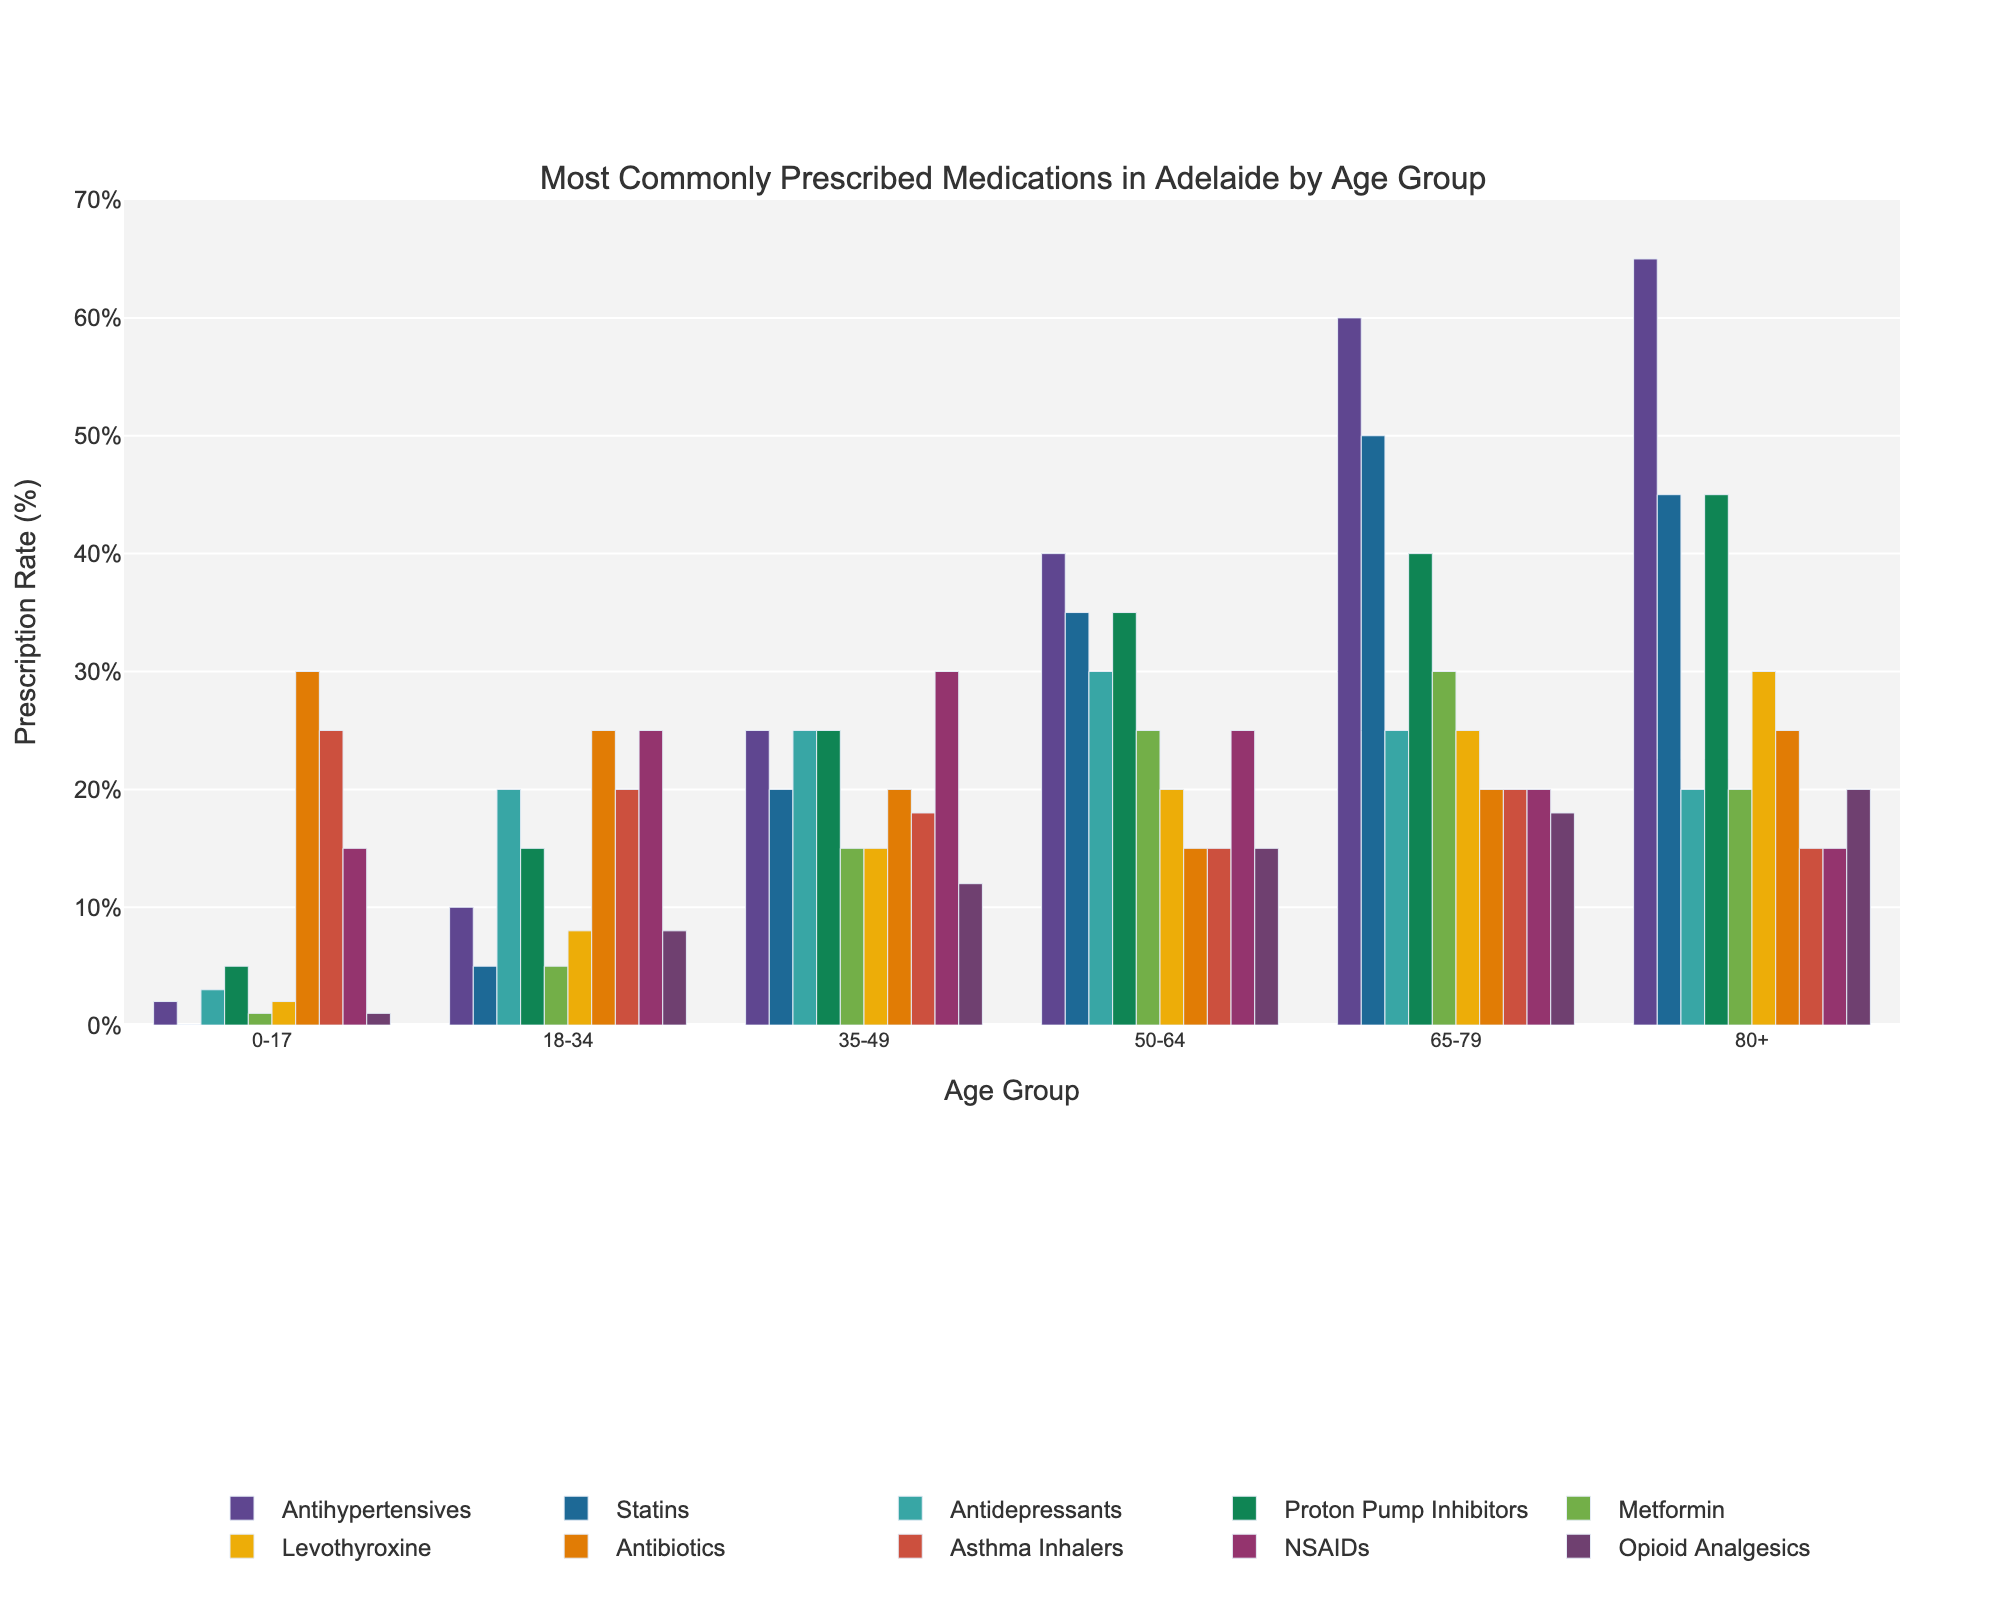Which medication is most commonly prescribed to the age group 0-17? By looking at the height of the bars for the age group 0-17, we observe the bar for Antibiotics is the tallest.
Answer: Antibiotics Which age group has the highest prescription rate for Statins? By comparing the heights of the Statins bars across all age groups, the tallest bar is for the age group 65-79.
Answer: 65-79 Which medication has the highest overall prescription rate across all age groups? By comparing the tallest bars for each medication across all age groups, Antihypertensives for the age group 80+ has the tallest bar overall.
Answer: Antihypertensives In the age group 50-64, how many more prescriptions for Antihypertensives are there compared to Metformin? We observe the height of the bars for Antihypertensives (40) and Metformin (25) in the 50-64 age group, and take the difference: 40 - 25.
Answer: 15 What is the sum of prescription rates for NSAIDs in age groups 18-34 and 35-49? Sum the height of the bars for NSAIDs in the 18-34 age group (25) and the 35-49 age group (30): 25 + 30.
Answer: 55 Which medication has a higher prescription rate in the age group 80+, Antidepressants or Opioid Analgesics? By comparing the heights of the bars for Antidepressants (20) and Opioid Analgesics (20) in the age group 80+, we see they are equal.
Answer: They are equal In the age group 35-49, which medication has the lowest prescription rate? By comparing the shortest bar for the age group 35-49, Metformin has the lowest height (15).
Answer: Metformin How do the prescription rates for Asthma Inhalers compare between the age groups 0-17 and 18-34? By comparing the heights of the bars for Asthma Inhalers, in the age group 0-17 it is 25 and in 18-34 it is 20. 25 is higher than 20.
Answer: Higher in 0-17 What is the difference in the prescription rates for Proton Pump Inhibitors between the 35-49 and 65-79 age groups? Observing the height of the bars for Proton Pump Inhibitors in the 35-49 age group (25) and the 65-79 age group (40), and computing the difference: 40 - 25.
Answer: 15 